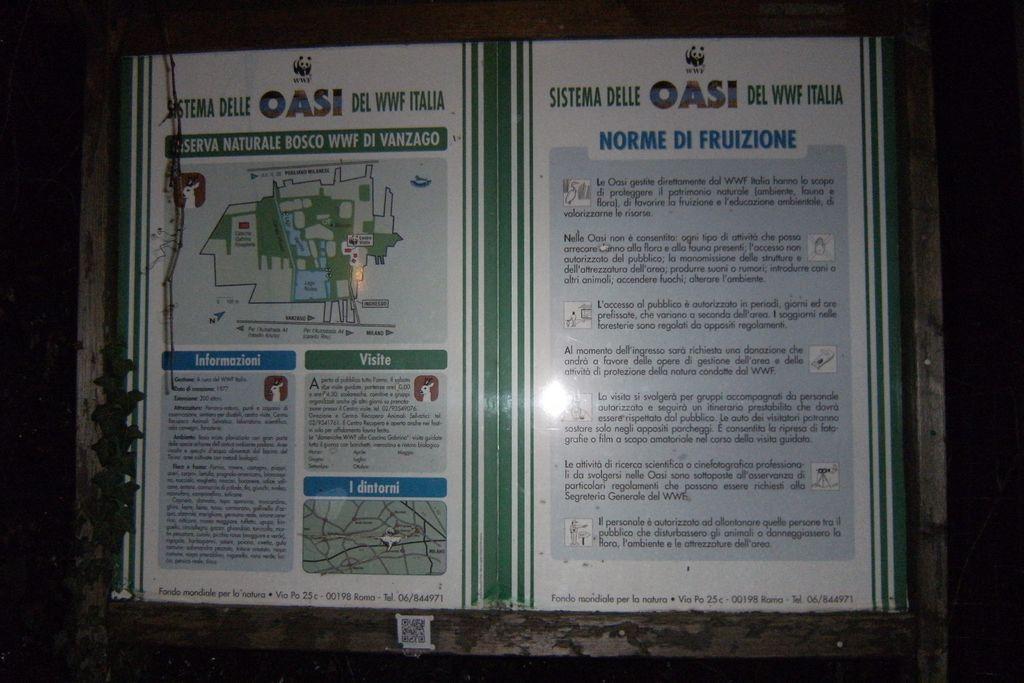What is the text in blue?
Keep it short and to the point. Norme di fruizione. What does the green title say?
Your answer should be compact. Sistema delle oasi del wwf italia. 